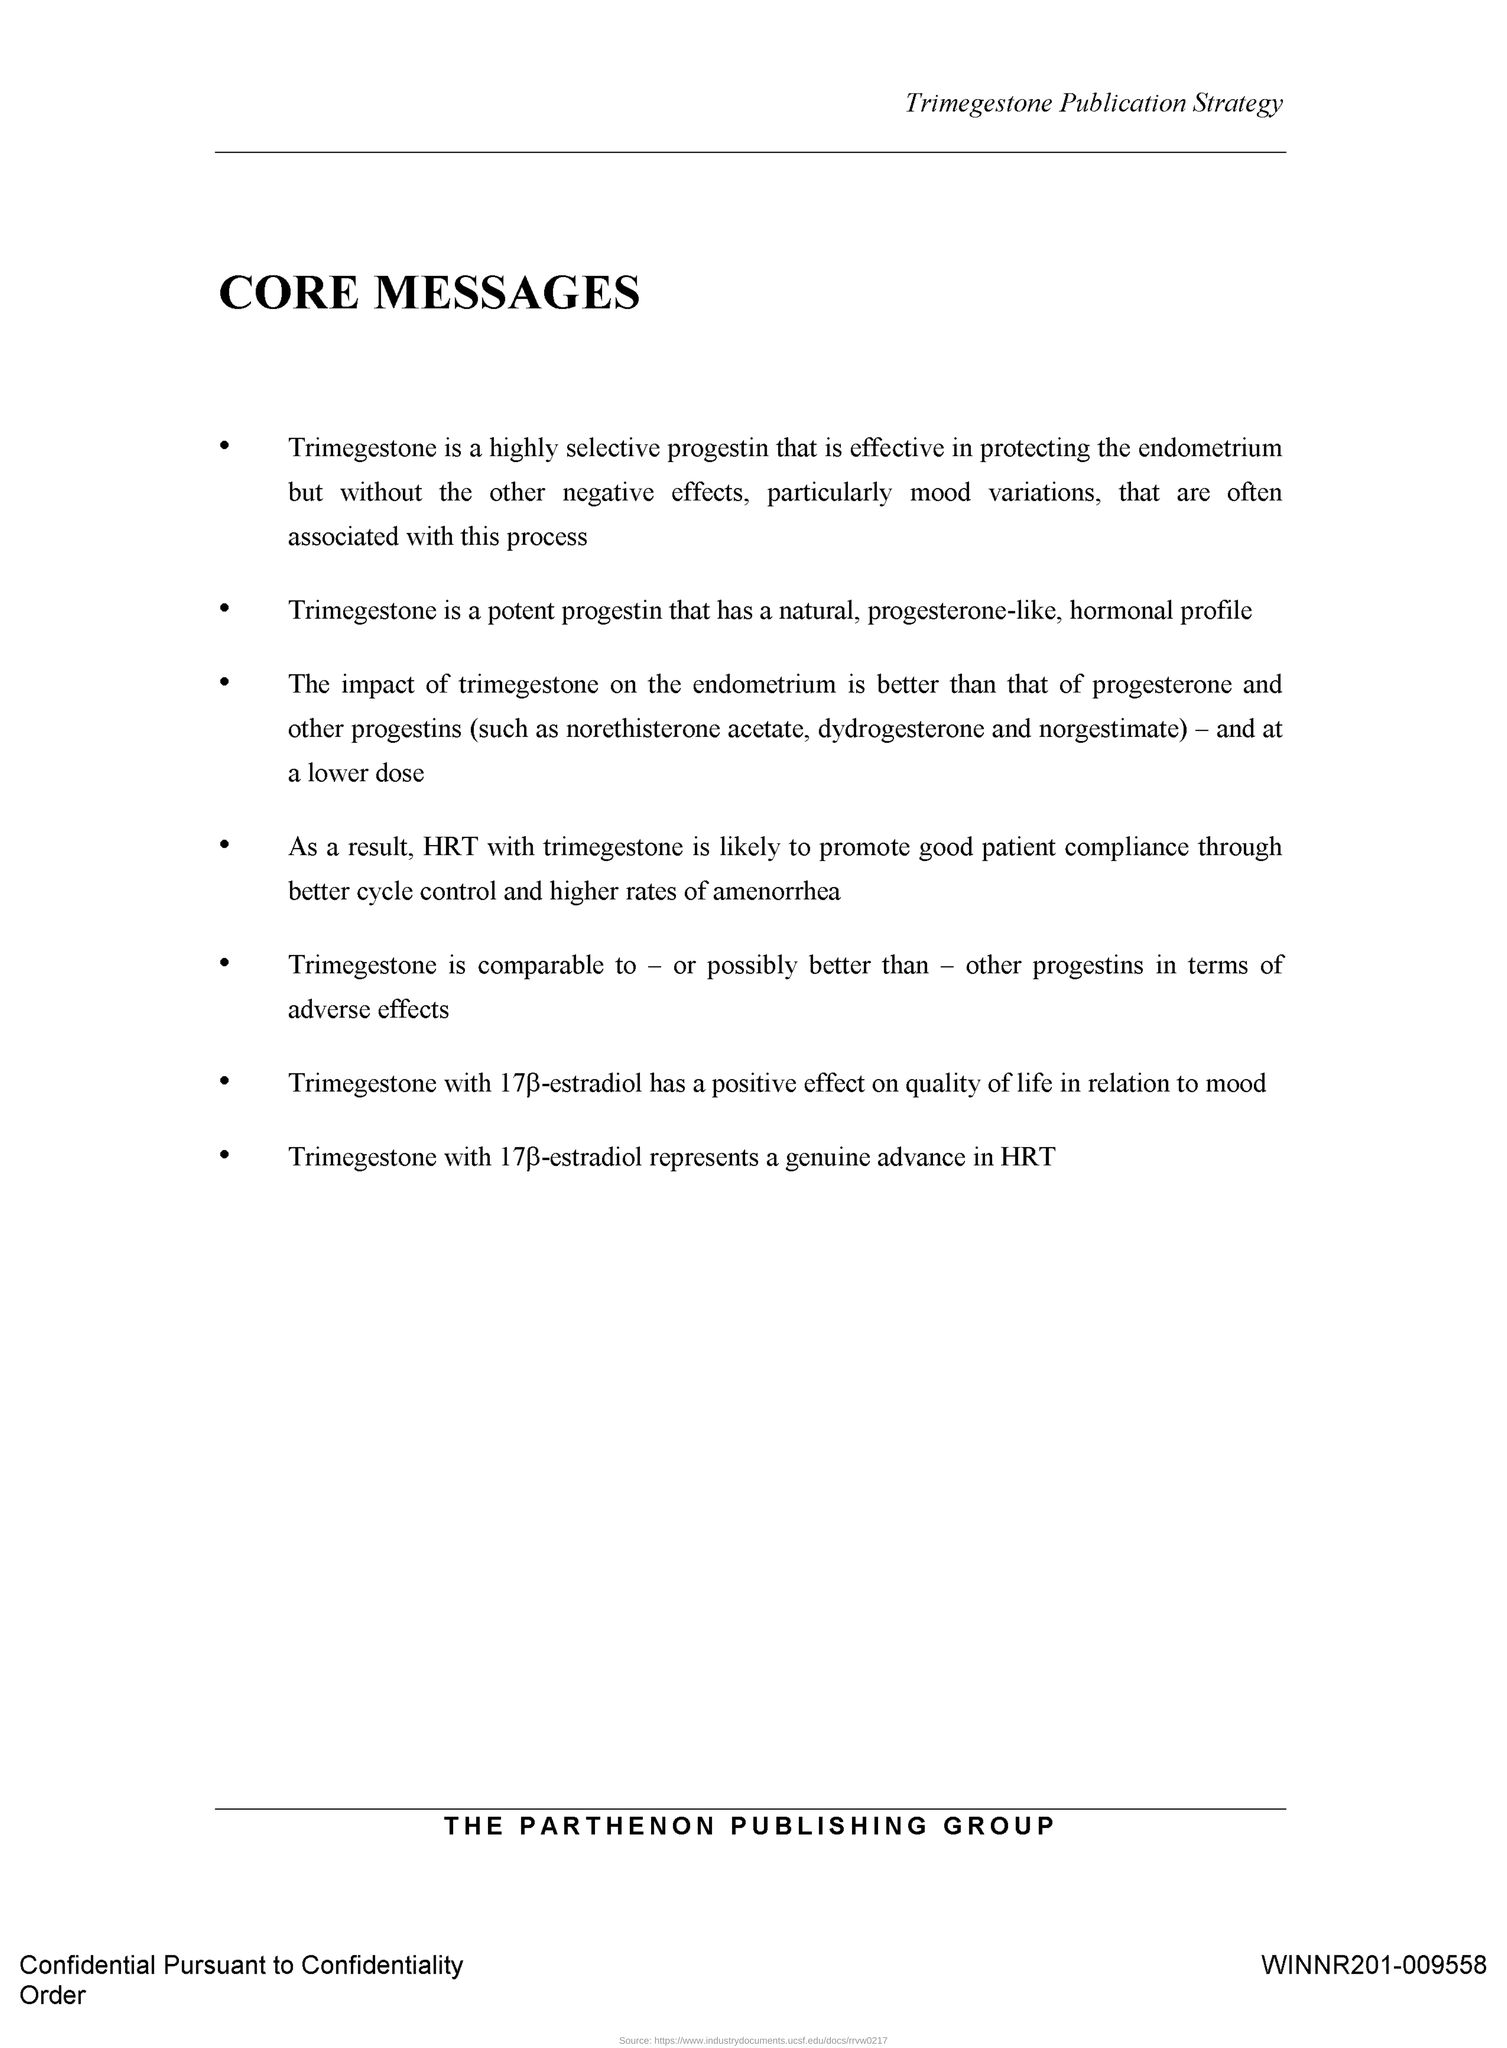What is a potent progestin that has a natural , progesterone-like, hormonal profile?
Provide a succinct answer. Trimegestone. What is the title of this document?
Provide a succinct answer. CORE MESSAGES. 